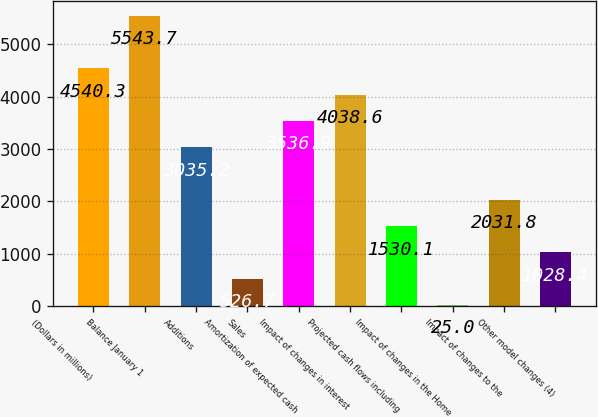Convert chart to OTSL. <chart><loc_0><loc_0><loc_500><loc_500><bar_chart><fcel>(Dollars in millions)<fcel>Balance January 1<fcel>Additions<fcel>Sales<fcel>Amortization of expected cash<fcel>Impact of changes in interest<fcel>Projected cash flows including<fcel>Impact of changes in the Home<fcel>Impact of changes to the<fcel>Other model changes (4)<nl><fcel>4540.3<fcel>5543.7<fcel>3035.2<fcel>526.7<fcel>3536.9<fcel>4038.6<fcel>1530.1<fcel>25<fcel>2031.8<fcel>1028.4<nl></chart> 